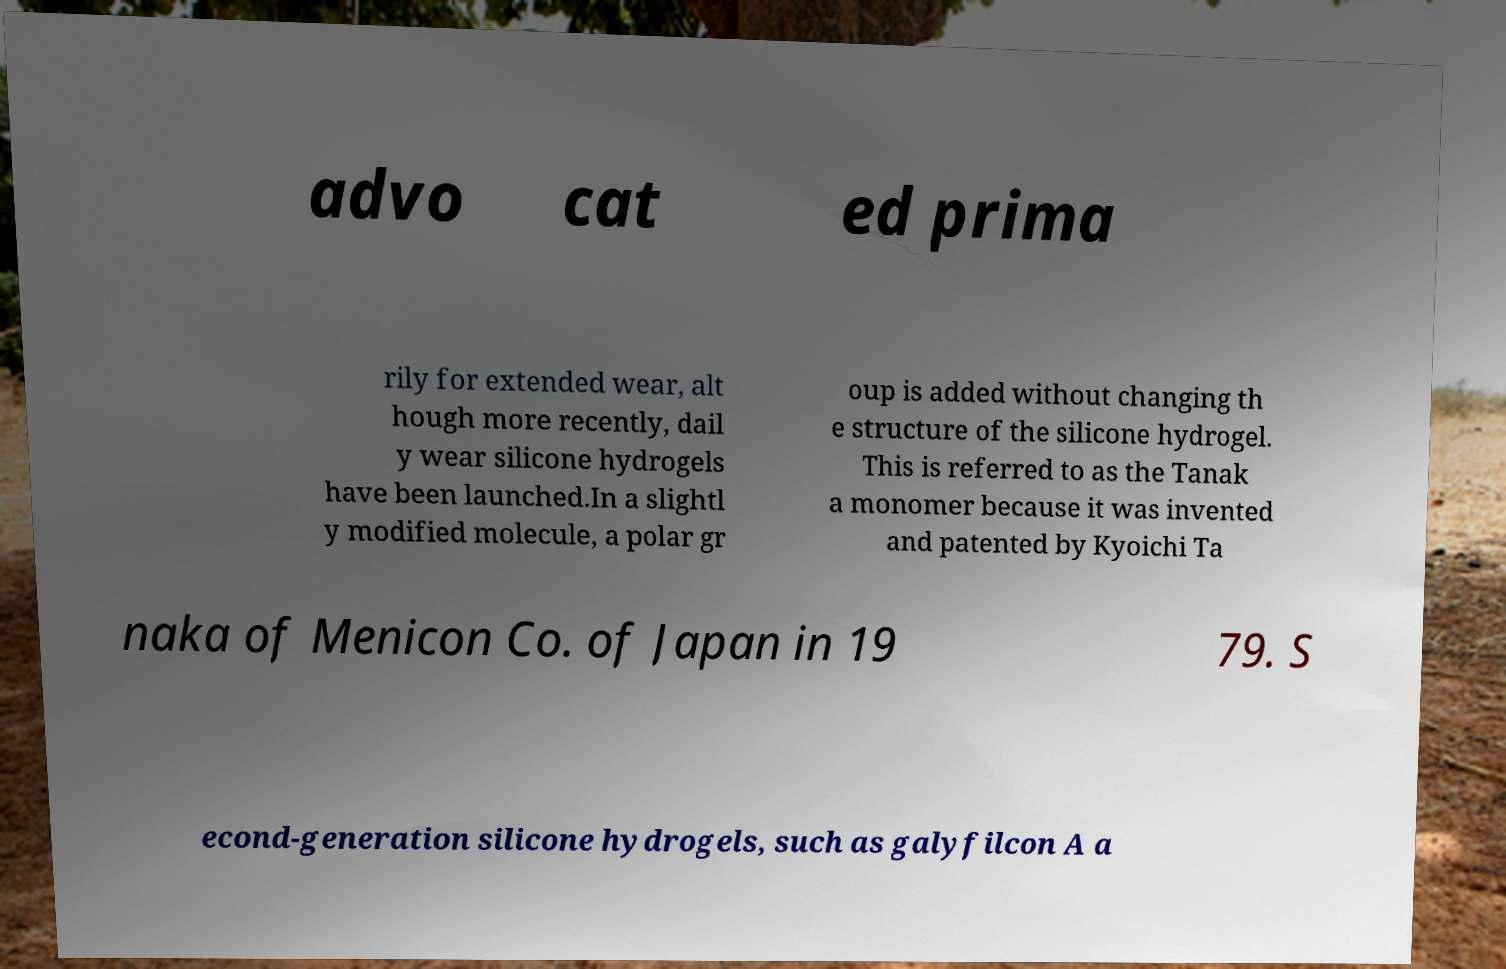Please identify and transcribe the text found in this image. advo cat ed prima rily for extended wear, alt hough more recently, dail y wear silicone hydrogels have been launched.In a slightl y modified molecule, a polar gr oup is added without changing th e structure of the silicone hydrogel. This is referred to as the Tanak a monomer because it was invented and patented by Kyoichi Ta naka of Menicon Co. of Japan in 19 79. S econd-generation silicone hydrogels, such as galyfilcon A a 